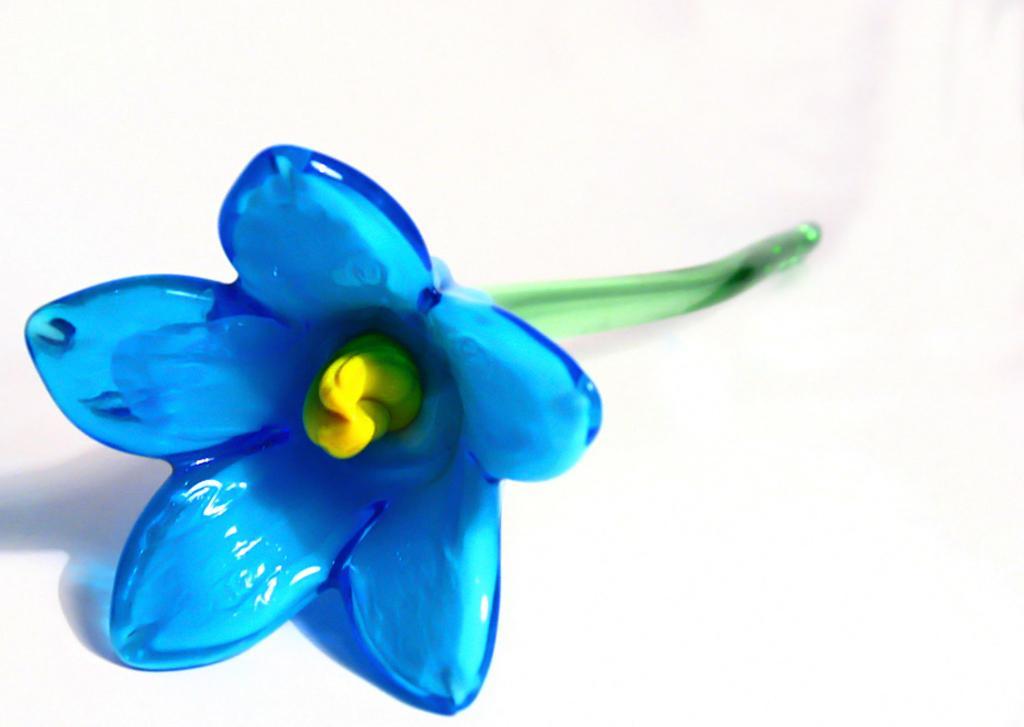In one or two sentences, can you explain what this image depicts? In this image there is an artificial flower. 